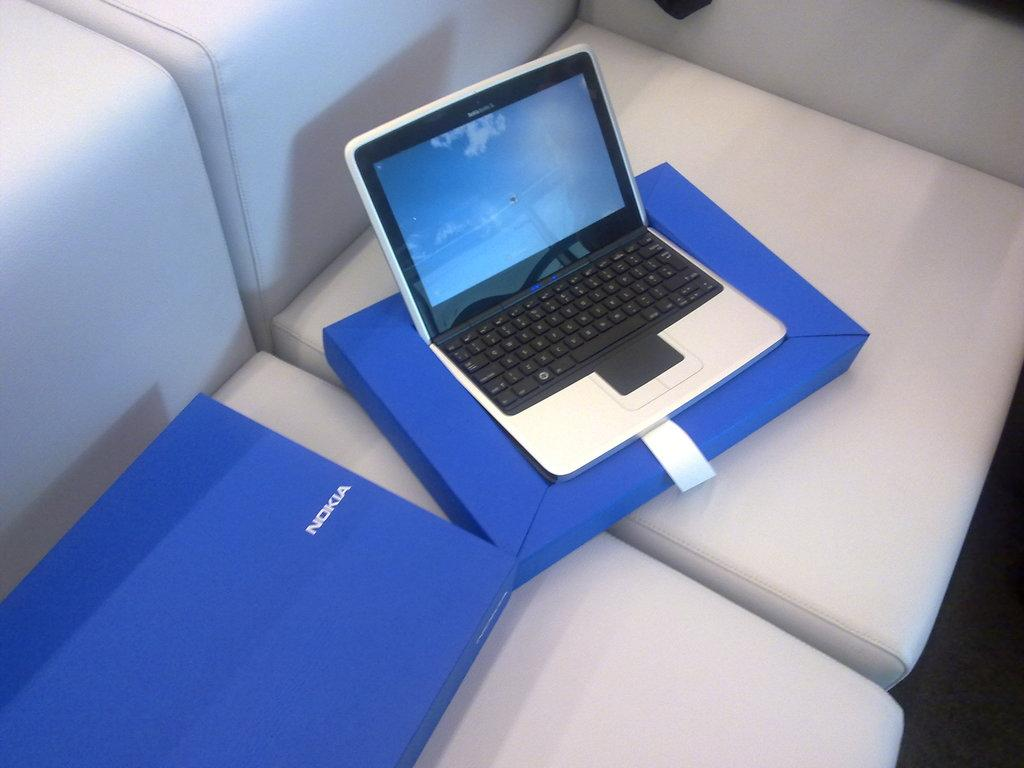<image>
Relay a brief, clear account of the picture shown. a Nokia blue box with laptop open on top 